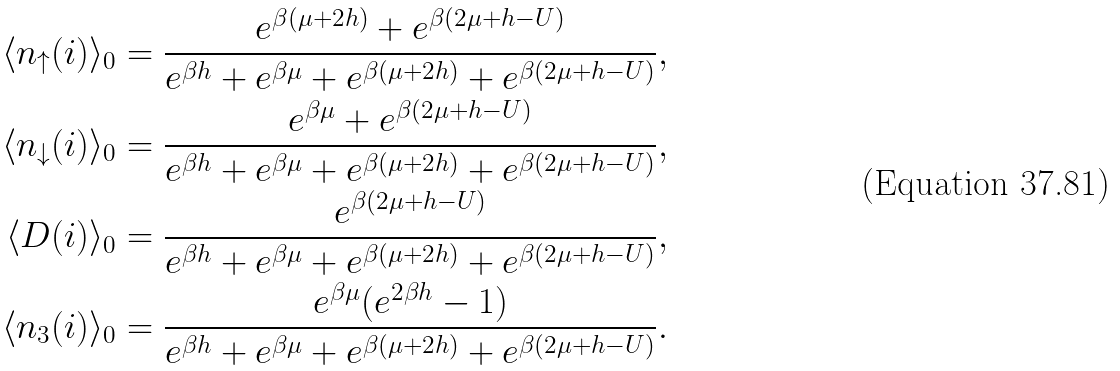<formula> <loc_0><loc_0><loc_500><loc_500>\langle n _ { \uparrow } ( i ) \rangle _ { 0 } & = \frac { e ^ { \beta ( \mu + 2 h ) } + e ^ { \beta ( 2 \mu + h - U ) } } { e ^ { \beta h } + e ^ { \beta \mu } + e ^ { \beta ( \mu + 2 h ) } + e ^ { \beta ( 2 \mu + h - U ) } } , \\ \langle n _ { \downarrow } ( i ) \rangle _ { 0 } & = \frac { e ^ { \beta \mu } + e ^ { \beta ( 2 \mu + h - U ) } } { e ^ { \beta h } + e ^ { \beta \mu } + e ^ { \beta ( \mu + 2 h ) } + e ^ { \beta ( 2 \mu + h - U ) } } , \\ \langle D ( i ) \rangle _ { 0 } & = \frac { e ^ { \beta ( 2 \mu + h - U ) } } { e ^ { \beta h } + e ^ { \beta \mu } + e ^ { \beta ( \mu + 2 h ) } + e ^ { \beta ( 2 \mu + h - U ) } } , \\ \langle n _ { 3 } ( i ) \rangle _ { 0 } & = \frac { e ^ { \beta \mu } ( e ^ { 2 \beta h } - 1 ) } { e ^ { \beta h } + e ^ { \beta \mu } + e ^ { \beta ( \mu + 2 h ) } + e ^ { \beta ( 2 \mu + h - U ) } } .</formula> 